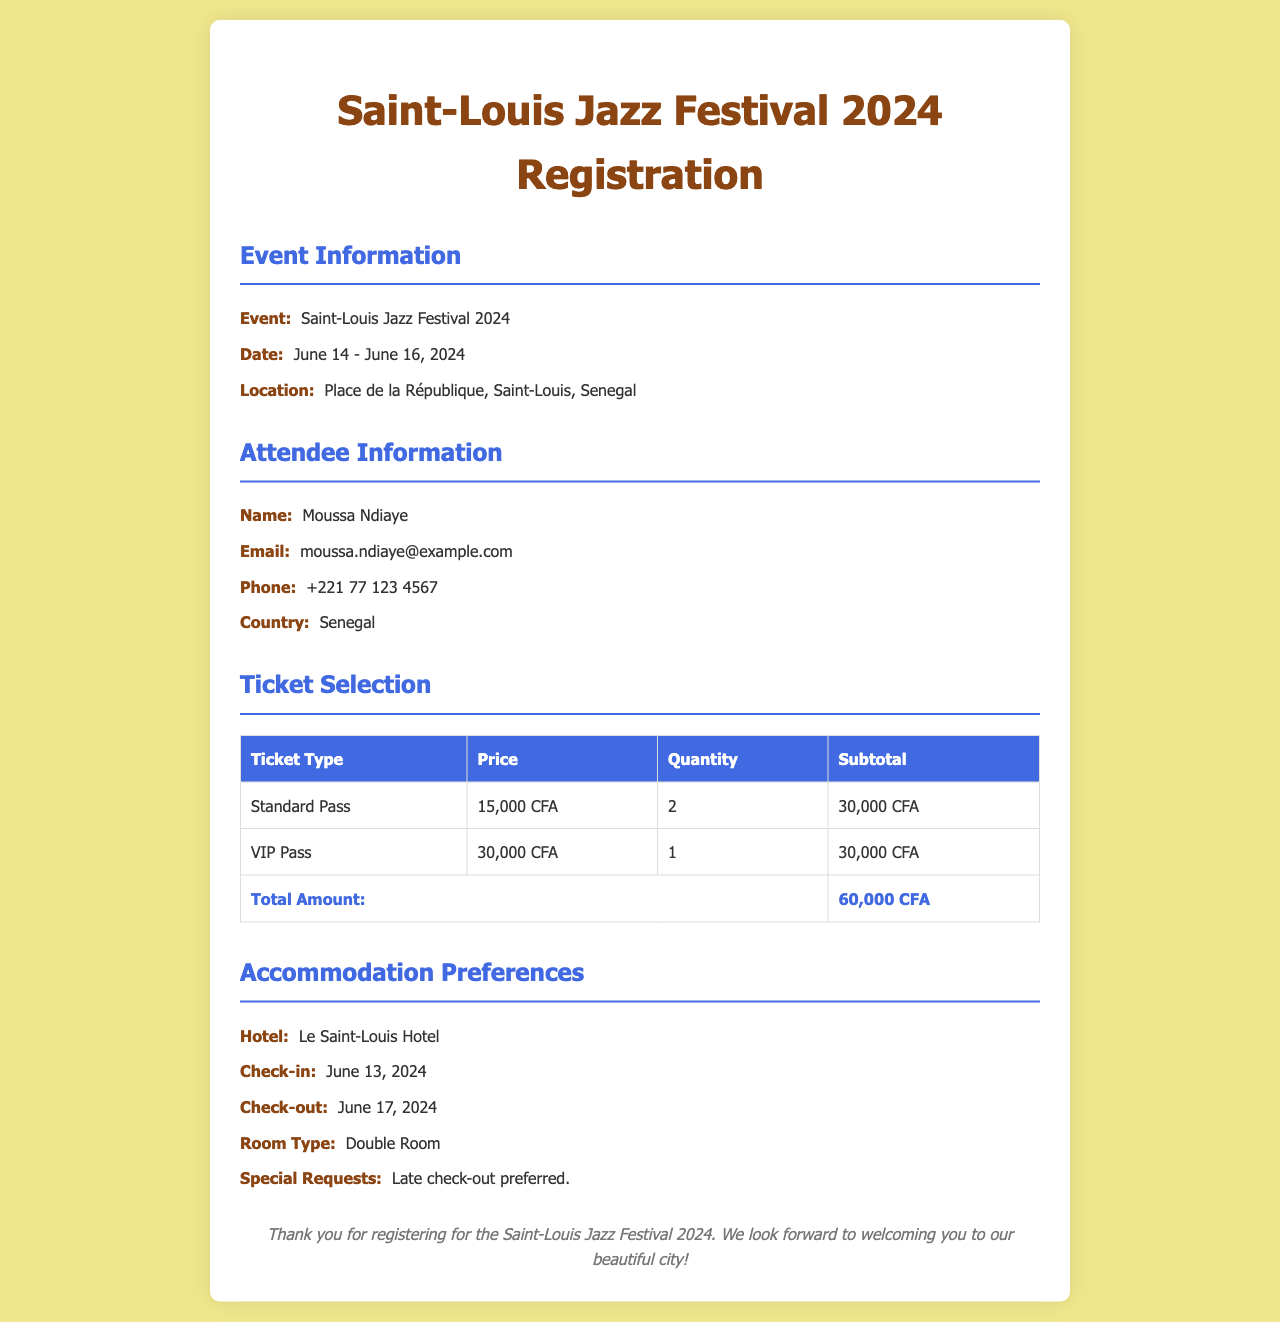What is the event name? The event name is explicitly stated at the beginning of the document under the event information section.
Answer: Saint-Louis Jazz Festival 2024 What are the dates of the festival? The dates of the festival are mentioned under the event information section.
Answer: June 14 - June 16, 2024 Who is the attendee? The attendee's name is listed in the attendee information section.
Answer: Moussa Ndiaye What type of accommodation is preferred? The preferred accommodation type can be found in the accommodation preferences section of the document.
Answer: Double Room What is the total amount for the tickets? The total amount is indicated at the bottom of the ticket selection table.
Answer: 60,000 CFA How many standard passes were selected? The quantity of standard passes selected is specified in the ticket selection table.
Answer: 2 What hotel will the attendee stay at? The hotel information is mentioned under the accommodation preferences section.
Answer: Le Saint-Louis Hotel When is the check-in date? The check-in date can be found in the accommodation preferences section.
Answer: June 13, 2024 What is the special request listed? The special request is provided in the accommodation preferences section.
Answer: Late check-out preferred 